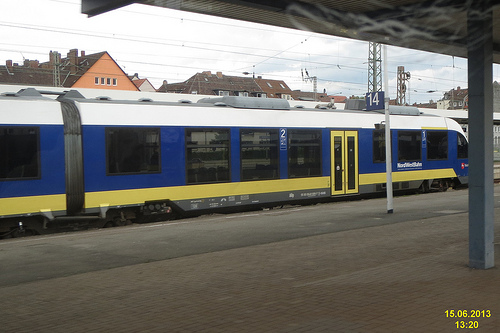Describe the atmosphere of the place shown in the image. The atmosphere of the train station appears calm and quiet, with no visible crowds. The overcast sky contributes a somewhat subdued lighting, which may evoke a quiet, perhaps off-peak travel time. The cleanliness and orderliness suggest an environment that is well-regulated and maintained. 